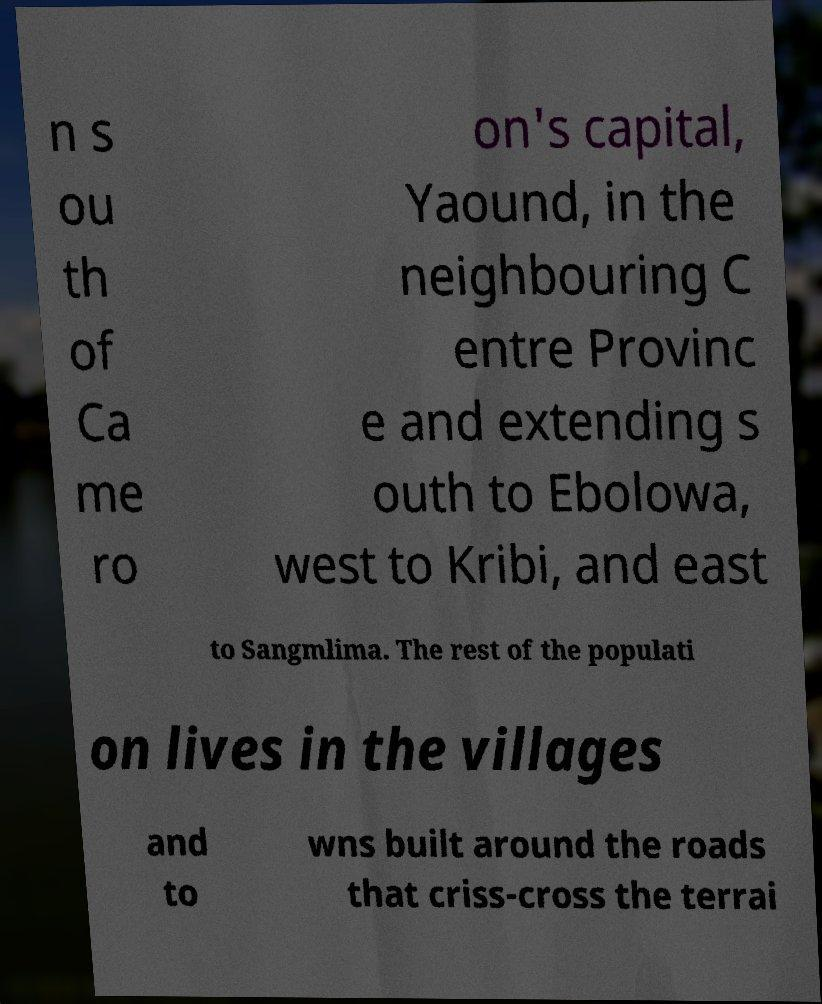For documentation purposes, I need the text within this image transcribed. Could you provide that? n s ou th of Ca me ro on's capital, Yaound, in the neighbouring C entre Provinc e and extending s outh to Ebolowa, west to Kribi, and east to Sangmlima. The rest of the populati on lives in the villages and to wns built around the roads that criss-cross the terrai 